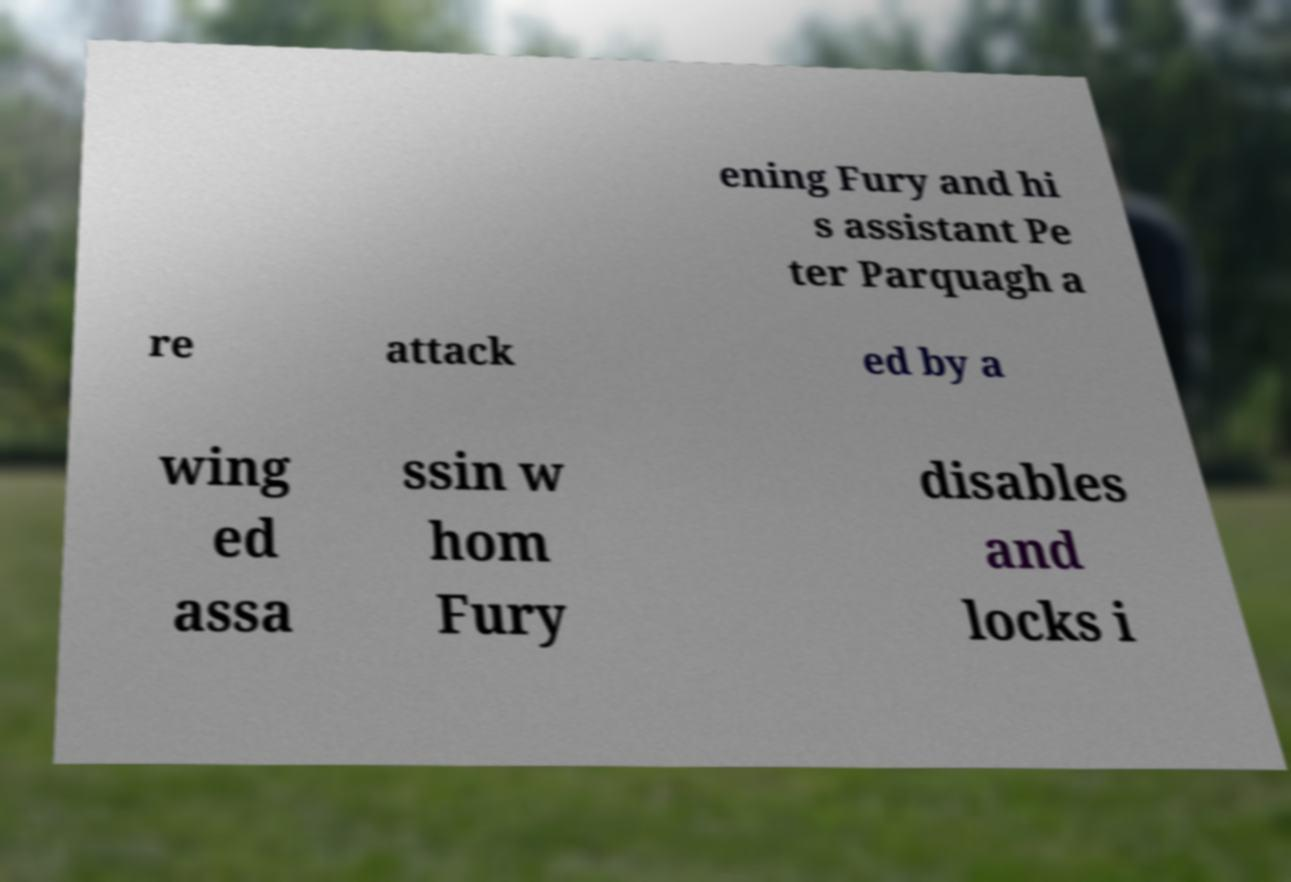For documentation purposes, I need the text within this image transcribed. Could you provide that? ening Fury and hi s assistant Pe ter Parquagh a re attack ed by a wing ed assa ssin w hom Fury disables and locks i 